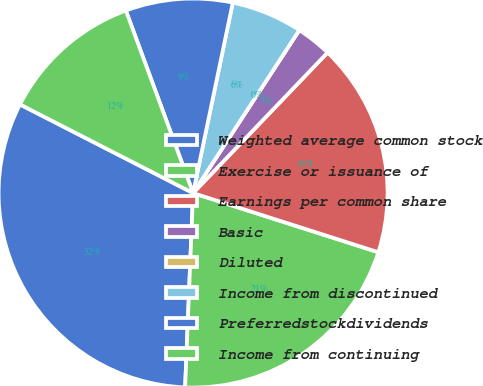Convert chart to OTSL. <chart><loc_0><loc_0><loc_500><loc_500><pie_chart><fcel>Weighted average common stock<fcel>Exercise or issuance of<fcel>Earnings per common share<fcel>Basic<fcel>Diluted<fcel>Income from discontinued<fcel>Preferredstockdividends<fcel>Income from continuing<nl><fcel>31.88%<fcel>20.73%<fcel>17.77%<fcel>2.96%<fcel>0.0%<fcel>5.92%<fcel>8.89%<fcel>11.85%<nl></chart> 